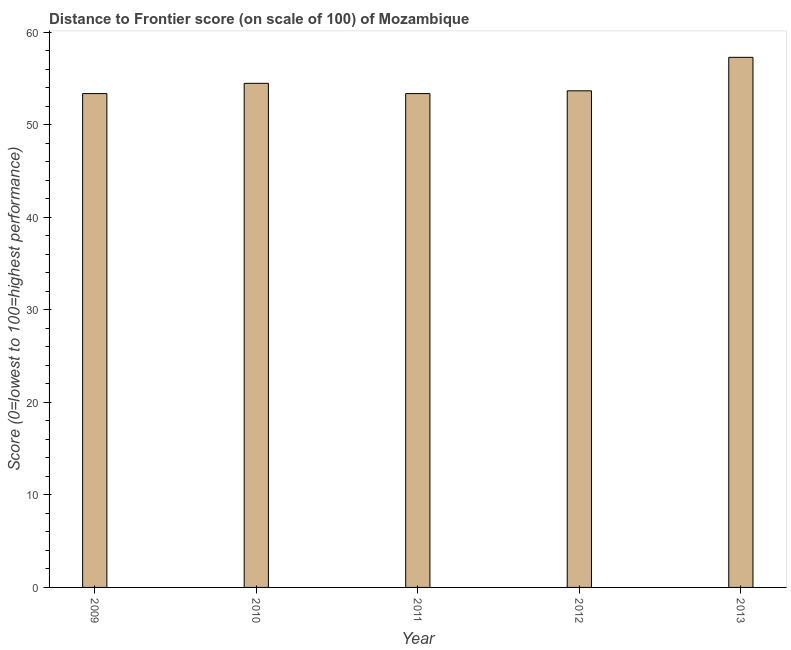What is the title of the graph?
Offer a terse response. Distance to Frontier score (on scale of 100) of Mozambique. What is the label or title of the X-axis?
Offer a very short reply. Year. What is the label or title of the Y-axis?
Provide a short and direct response. Score (0=lowest to 100=highest performance). What is the distance to frontier score in 2012?
Provide a short and direct response. 53.69. Across all years, what is the maximum distance to frontier score?
Your response must be concise. 57.31. Across all years, what is the minimum distance to frontier score?
Offer a terse response. 53.39. In which year was the distance to frontier score maximum?
Offer a terse response. 2013. What is the sum of the distance to frontier score?
Keep it short and to the point. 272.28. What is the difference between the distance to frontier score in 2012 and 2013?
Keep it short and to the point. -3.62. What is the average distance to frontier score per year?
Offer a very short reply. 54.46. What is the median distance to frontier score?
Provide a succinct answer. 53.69. Do a majority of the years between 2009 and 2013 (inclusive) have distance to frontier score greater than 20 ?
Your answer should be compact. Yes. What is the ratio of the distance to frontier score in 2009 to that in 2013?
Your response must be concise. 0.93. Is the distance to frontier score in 2010 less than that in 2011?
Your answer should be very brief. No. What is the difference between the highest and the second highest distance to frontier score?
Keep it short and to the point. 2.81. Is the sum of the distance to frontier score in 2011 and 2012 greater than the maximum distance to frontier score across all years?
Your response must be concise. Yes. What is the difference between the highest and the lowest distance to frontier score?
Ensure brevity in your answer.  3.92. In how many years, is the distance to frontier score greater than the average distance to frontier score taken over all years?
Offer a terse response. 2. How many bars are there?
Your answer should be very brief. 5. Are all the bars in the graph horizontal?
Offer a very short reply. No. What is the difference between two consecutive major ticks on the Y-axis?
Your answer should be very brief. 10. Are the values on the major ticks of Y-axis written in scientific E-notation?
Offer a terse response. No. What is the Score (0=lowest to 100=highest performance) in 2009?
Ensure brevity in your answer.  53.39. What is the Score (0=lowest to 100=highest performance) in 2010?
Ensure brevity in your answer.  54.5. What is the Score (0=lowest to 100=highest performance) of 2011?
Your response must be concise. 53.39. What is the Score (0=lowest to 100=highest performance) in 2012?
Provide a succinct answer. 53.69. What is the Score (0=lowest to 100=highest performance) in 2013?
Ensure brevity in your answer.  57.31. What is the difference between the Score (0=lowest to 100=highest performance) in 2009 and 2010?
Ensure brevity in your answer.  -1.11. What is the difference between the Score (0=lowest to 100=highest performance) in 2009 and 2011?
Give a very brief answer. 0. What is the difference between the Score (0=lowest to 100=highest performance) in 2009 and 2012?
Provide a succinct answer. -0.3. What is the difference between the Score (0=lowest to 100=highest performance) in 2009 and 2013?
Provide a succinct answer. -3.92. What is the difference between the Score (0=lowest to 100=highest performance) in 2010 and 2011?
Your response must be concise. 1.11. What is the difference between the Score (0=lowest to 100=highest performance) in 2010 and 2012?
Your answer should be very brief. 0.81. What is the difference between the Score (0=lowest to 100=highest performance) in 2010 and 2013?
Keep it short and to the point. -2.81. What is the difference between the Score (0=lowest to 100=highest performance) in 2011 and 2012?
Your answer should be compact. -0.3. What is the difference between the Score (0=lowest to 100=highest performance) in 2011 and 2013?
Give a very brief answer. -3.92. What is the difference between the Score (0=lowest to 100=highest performance) in 2012 and 2013?
Ensure brevity in your answer.  -3.62. What is the ratio of the Score (0=lowest to 100=highest performance) in 2009 to that in 2013?
Make the answer very short. 0.93. What is the ratio of the Score (0=lowest to 100=highest performance) in 2010 to that in 2013?
Ensure brevity in your answer.  0.95. What is the ratio of the Score (0=lowest to 100=highest performance) in 2011 to that in 2012?
Give a very brief answer. 0.99. What is the ratio of the Score (0=lowest to 100=highest performance) in 2011 to that in 2013?
Your answer should be very brief. 0.93. What is the ratio of the Score (0=lowest to 100=highest performance) in 2012 to that in 2013?
Offer a terse response. 0.94. 